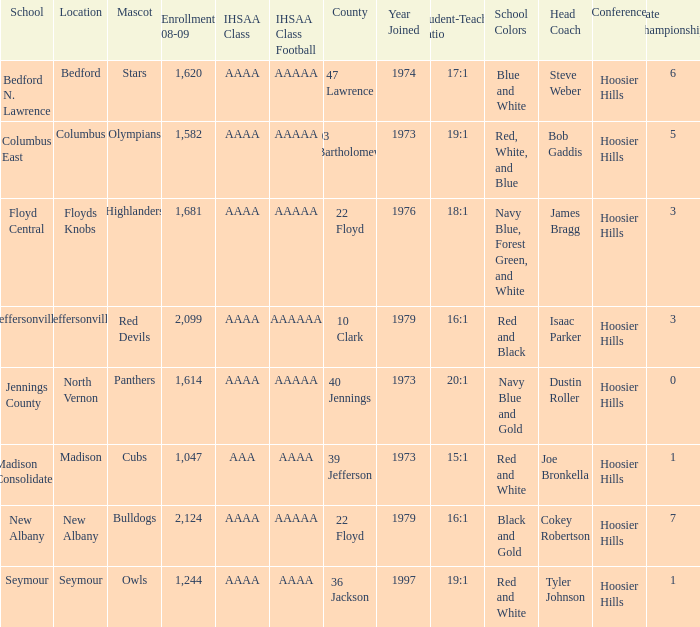What's the IHSAA Class Football if the panthers are the mascot? AAAAA. 